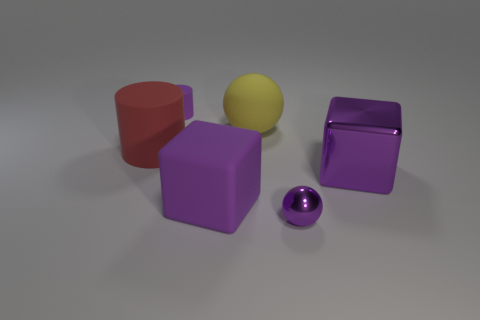There is a tiny purple thing that is behind the yellow object; what number of metallic things are right of it?
Your response must be concise. 2. Do the big cube right of the big yellow rubber thing and the small sphere have the same material?
Provide a succinct answer. Yes. Is there any other thing that is the same material as the yellow sphere?
Your answer should be compact. Yes. What is the size of the purple object behind the large object that is to the left of the tiny purple rubber thing?
Your answer should be compact. Small. There is a purple matte object right of the small purple thing that is behind the small object on the right side of the yellow rubber sphere; what is its size?
Make the answer very short. Large. Do the purple shiny object that is in front of the big shiny block and the tiny object that is on the left side of the rubber block have the same shape?
Offer a very short reply. No. What number of other objects are the same color as the large rubber cube?
Provide a succinct answer. 3. Is the size of the rubber cylinder behind the red rubber object the same as the big purple matte block?
Offer a very short reply. No. Are the block that is to the right of the tiny metal ball and the object that is left of the purple matte cylinder made of the same material?
Provide a short and direct response. No. Is there a thing that has the same size as the matte block?
Provide a short and direct response. Yes. 